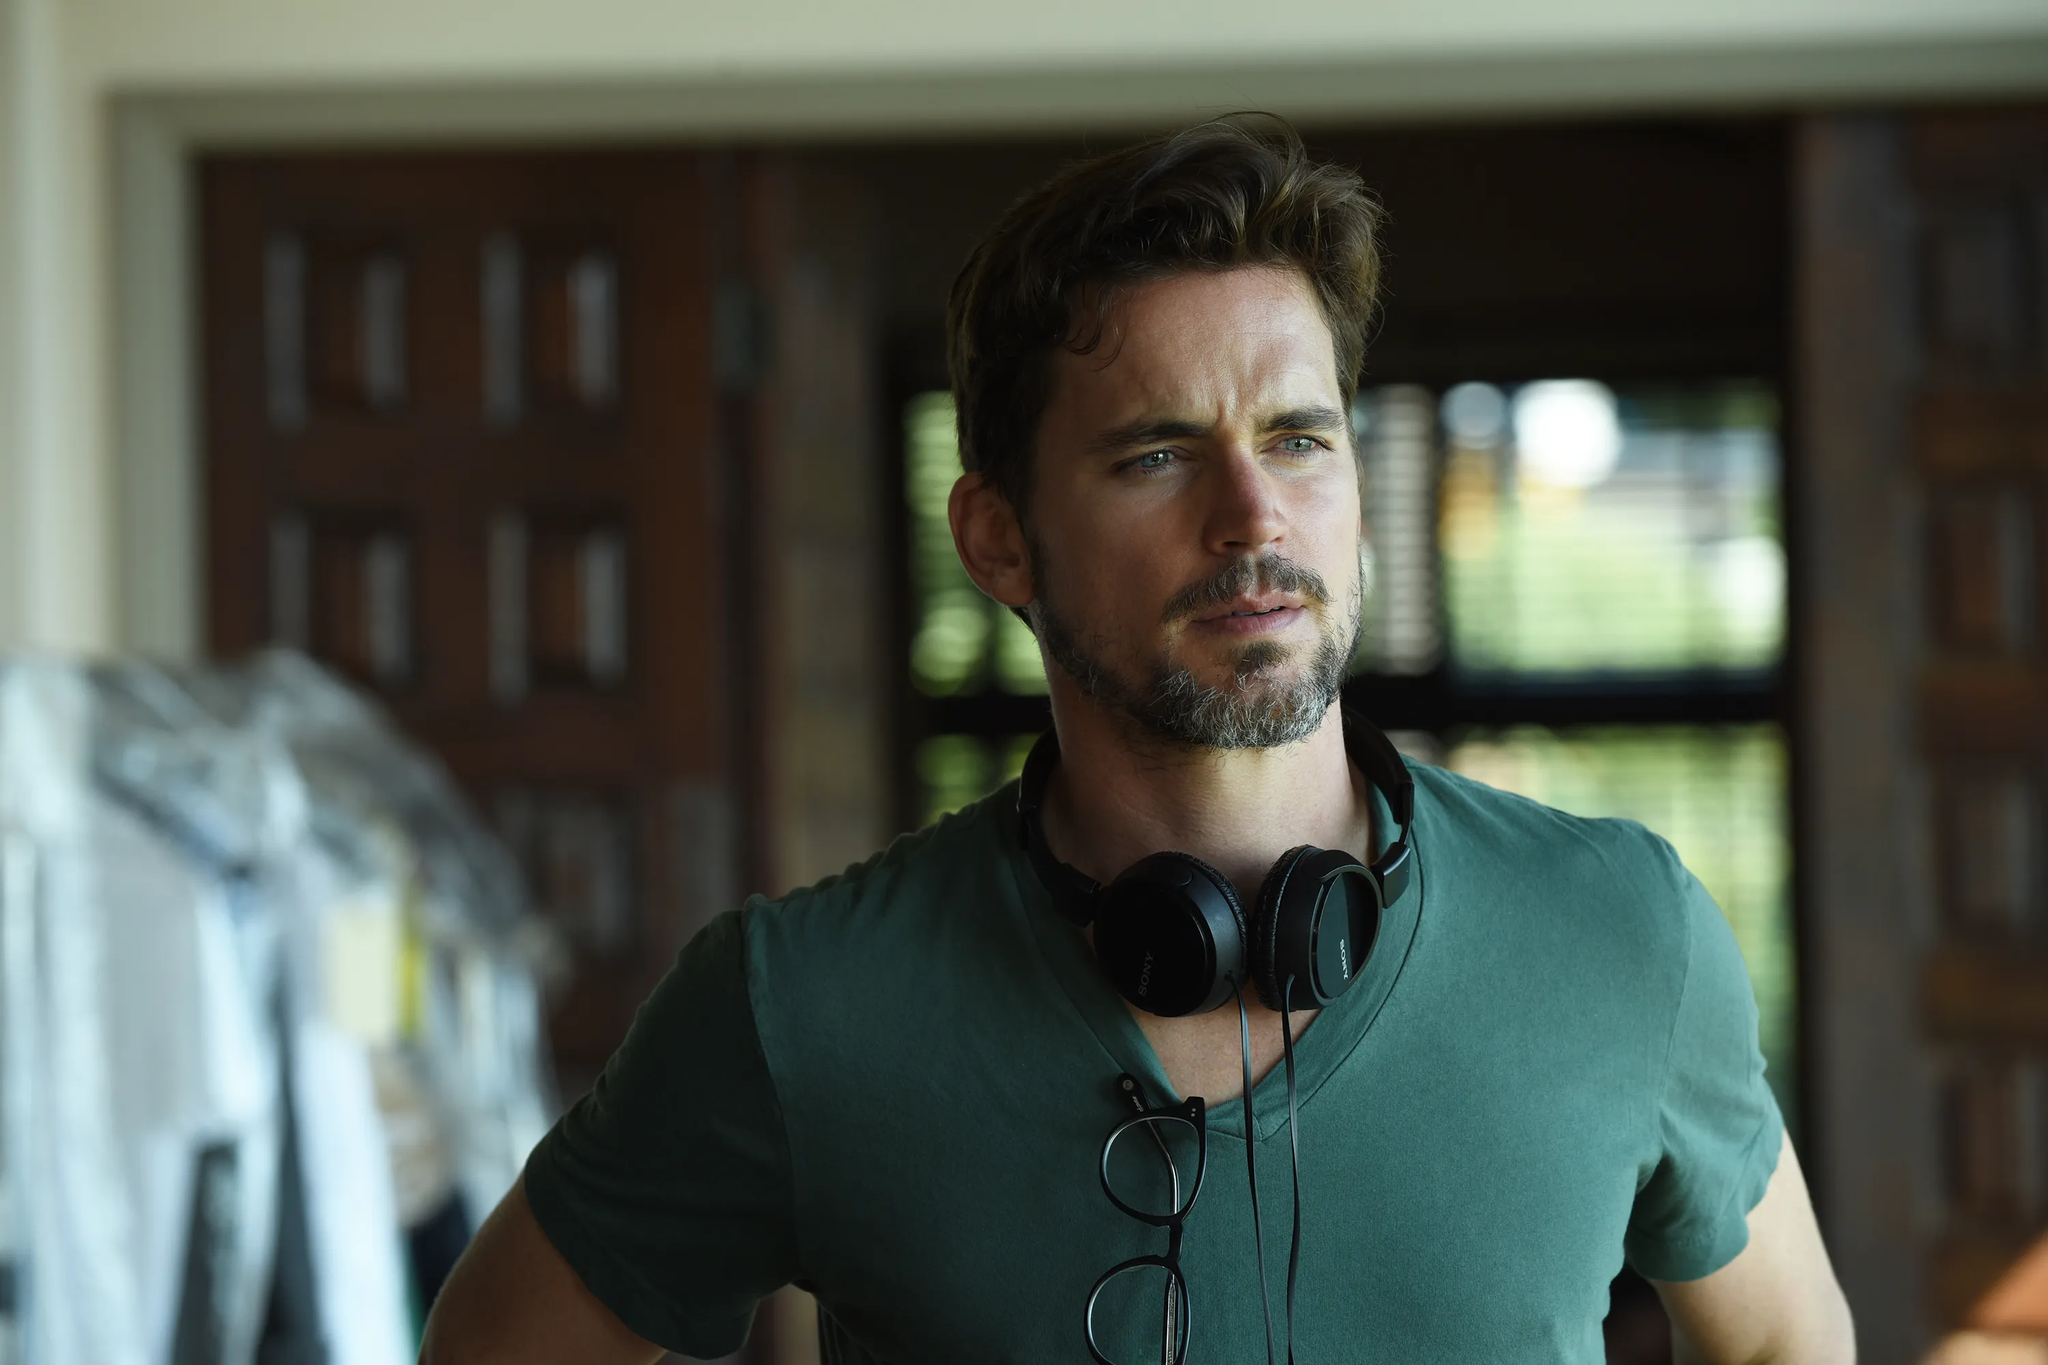Can you tell more about the setting? The setting of the image is a room with a rustic character, highlighted by a wooden door and window. The warm tones of the wood create a cozy and inviting atmosphere. There also appears to be some clothing or fabric draped over a surface in the background, indicating that this might be a personal space, perhaps a home or a studio. What do you think he's listening to? Given his contemplative expression, he could be listening to something deeply emotional or thought-provoking, like classical music, a podcast, or an audiobook. It's also possible that he's an artist absorbing new material for inspiration. Imagine he's hearing a message from the future. How does he react? As he listens to the futuristic message, his expression changes from contemplation to surprise, then to determination. His eyes widen slightly, and he straightens his posture as if ready to take on a challenge that the message brings. This adds a layer of intrigue, making the image a snapshot of a pivotal moment that could alter his path dramatically. Describe a realistic scenario where this image could be from a movie scene. In a movie, this image could depict a moment where the character played by the man is in his personal study, preparing for a critical decision. The music he's listening to is the soundtrack to his life, helping him sort through his thoughts and feelings. As he stands there, the viewer gets a sense of the gravity of the situation he’s about to face—a turning point in the storyline where he must make a decision that will impact the rest of the film. Describe a short realistic scenario. This could be a snapshot of a musician in his home studio, taking a moment to gather his thoughts before recording a new track. The room, filled with rich wood textures, serves as a tranquil, inspirational space for his creative process. 